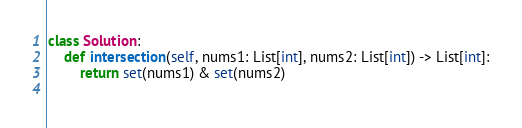<code> <loc_0><loc_0><loc_500><loc_500><_Python_>class Solution:
    def intersection(self, nums1: List[int], nums2: List[int]) -> List[int]:
        return set(nums1) & set(nums2)
        </code> 